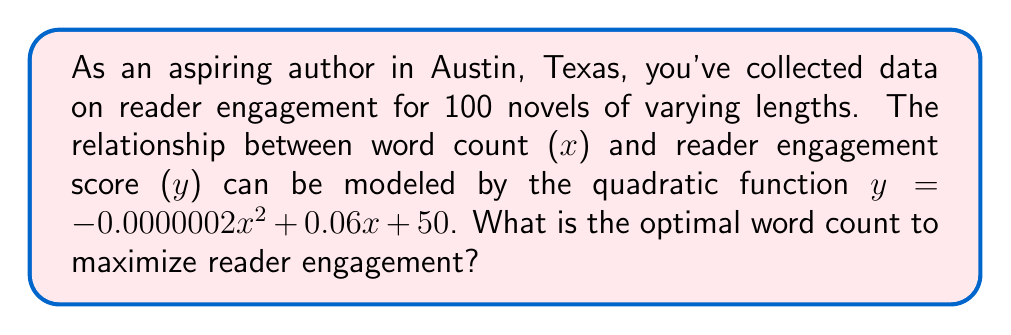Teach me how to tackle this problem. To find the optimal word count that maximizes reader engagement, we need to find the vertex of the parabola described by the given quadratic function. The steps are as follows:

1. The general form of a quadratic function is $y = ax^2 + bx + c$, where:
   $a = -0.0000002$
   $b = 0.06$
   $c = 50$

2. For a quadratic function, the x-coordinate of the vertex is given by the formula:
   $$x = -\frac{b}{2a}$$

3. Substituting the values:
   $$x = -\frac{0.06}{2(-0.0000002)}$$

4. Simplifying:
   $$x = \frac{0.06}{0.0000004} = 150,000$$

5. To verify this is a maximum (not a minimum), we check that $a < 0$, which is true in this case.

6. Therefore, the optimal word count to maximize reader engagement is 150,000 words.
Answer: 150,000 words 